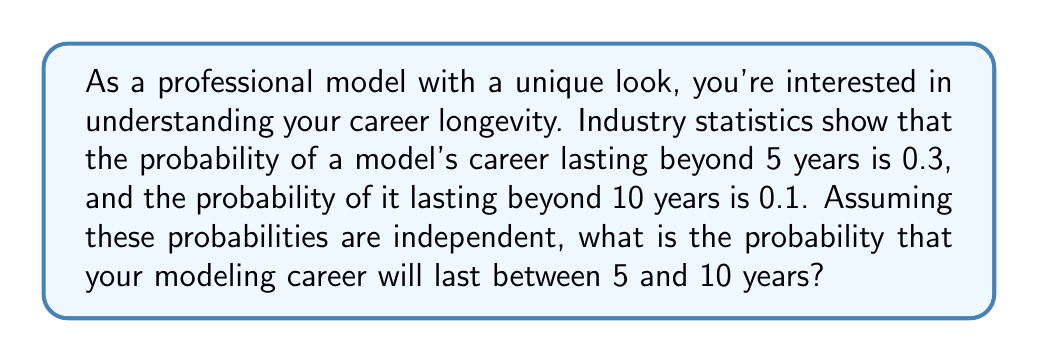Can you solve this math problem? Let's approach this step-by-step:

1) Let's define our events:
   A: Career lasts beyond 5 years
   B: Career lasts beyond 10 years

2) We're given:
   $P(A) = 0.3$
   $P(B) = 0.1$

3) We want to find the probability that the career lasts between 5 and 10 years. This can be expressed as the probability of lasting beyond 5 years MINUS the probability of lasting beyond 10 years.

4) In probability notation, this is:
   $P(5 < X \leq 10) = P(A) - P(B)$

5) We can simply substitute the given probabilities:
   $P(5 < X \leq 10) = 0.3 - 0.1 = 0.2$

6) Therefore, the probability that your modeling career will last between 5 and 10 years is 0.2 or 20%.

Note: This calculation assumes that the probabilities of lasting beyond 5 years and beyond 10 years are independent, which may not always be the case in real-world scenarios. In reality, there might be some correlation between these events.
Answer: The probability that your modeling career will last between 5 and 10 years is 0.2 or 20%. 